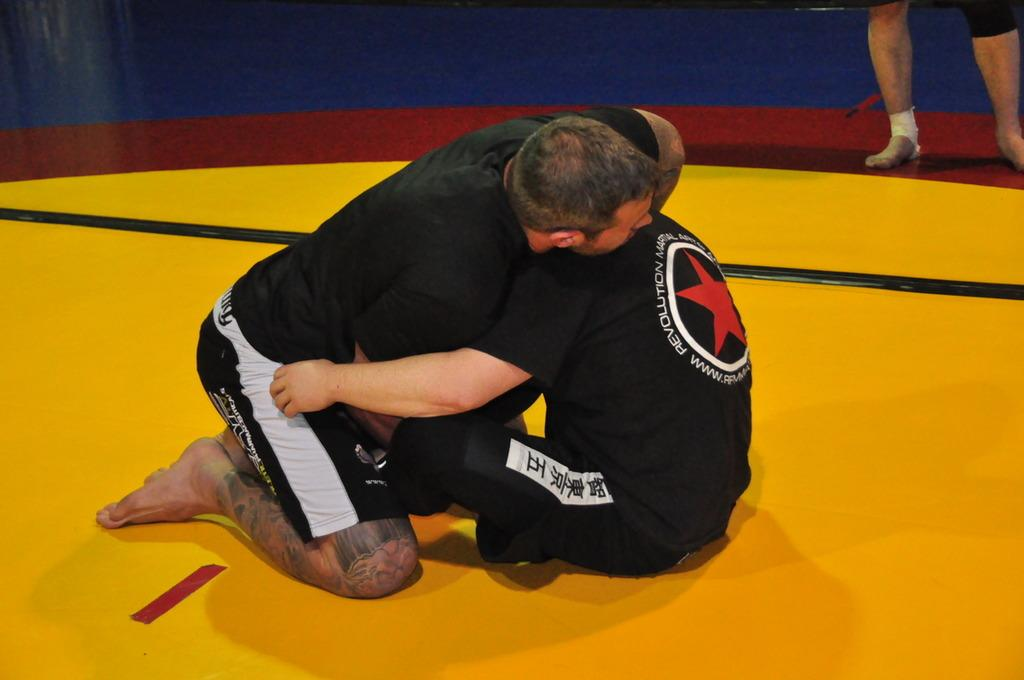<image>
Create a compact narrative representing the image presented. the word revolution that is on a shirt 